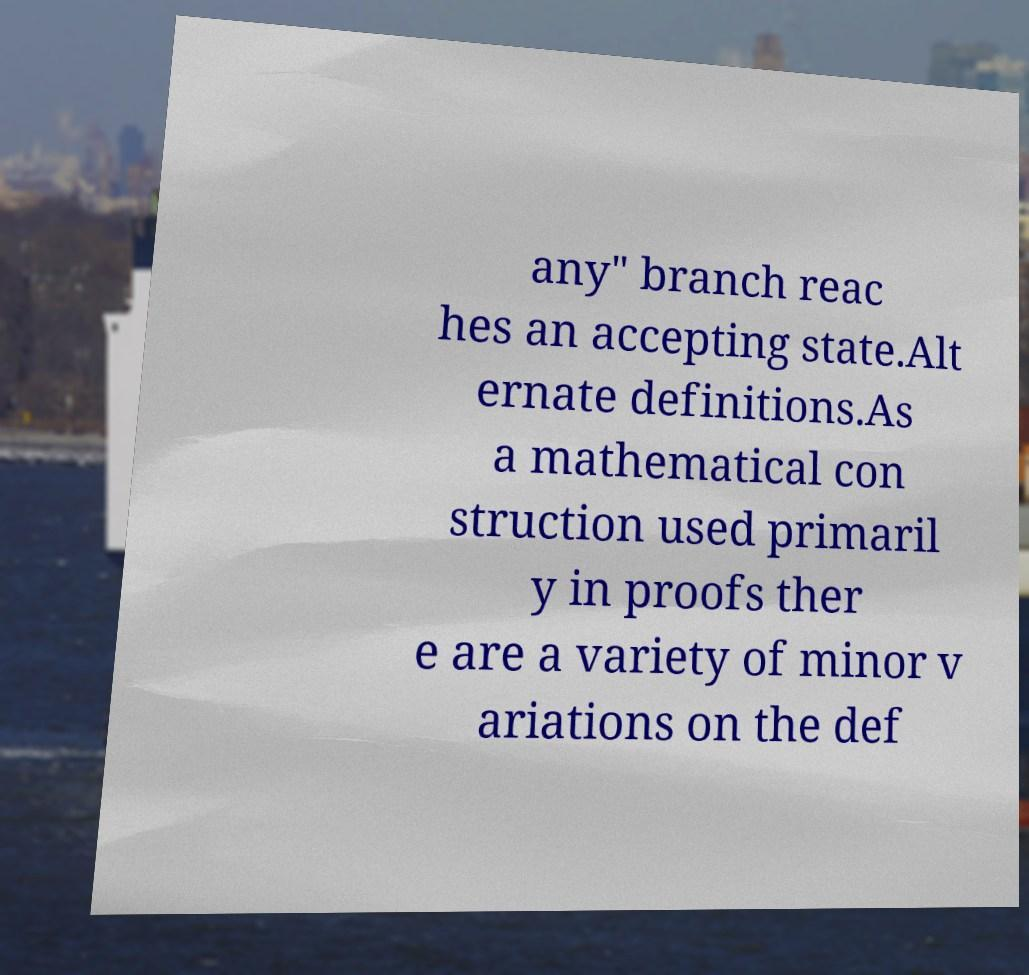Could you extract and type out the text from this image? any" branch reac hes an accepting state.Alt ernate definitions.As a mathematical con struction used primaril y in proofs ther e are a variety of minor v ariations on the def 